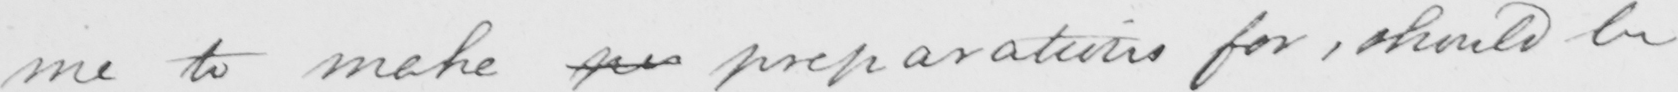Please transcribe the handwritten text in this image. me to make pr preparations for , should be 